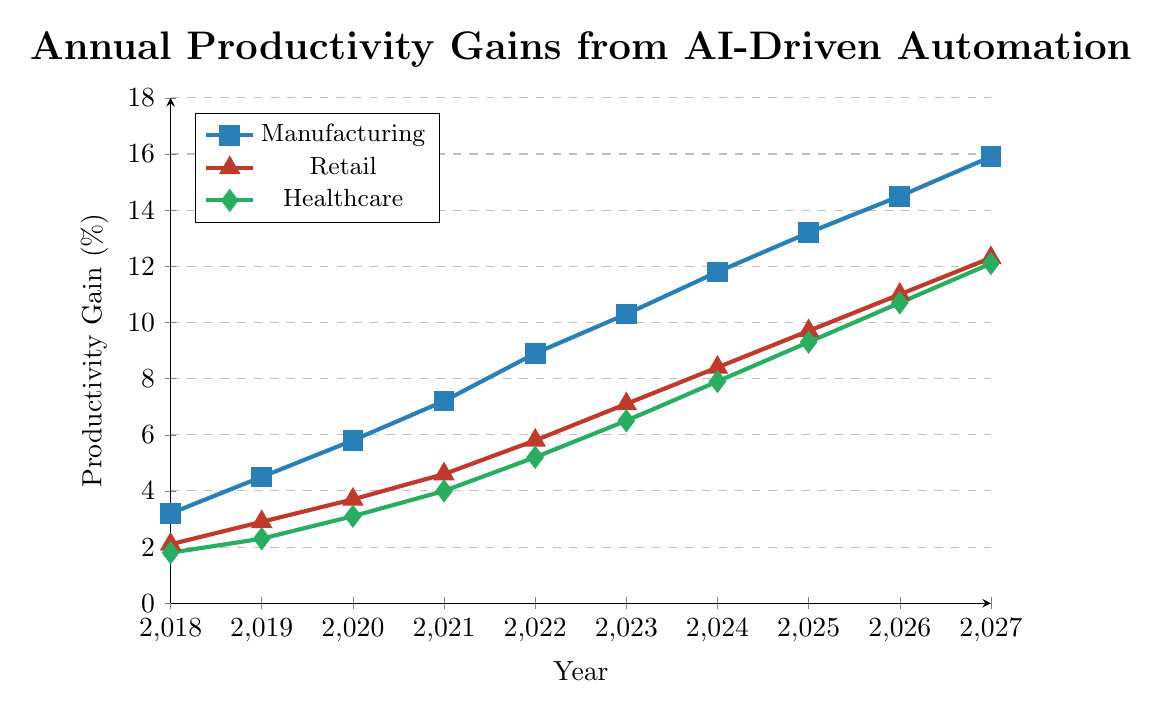What sector had the highest productivity gains in 2023? In 2023, compare the productivity gains across Manufacturing, Retail, and Healthcare sectors. Manufacturing shows 10.3%, Retail shows 7.1%, and Healthcare shows 6.5%. Thus, Manufacturing had the highest productivity gains.
Answer: Manufacturing How much did the productivity gain in the Healthcare sector increase from 2018 to 2027? Calculate the difference in productivity gains for the Healthcare sector between 2027 and 2018. It was 12.1% in 2027 and 1.8% in 2018. So, 12.1% - 1.8% = 10.3%.
Answer: 10.3% Which sector had the smallest productivity gain in 2020? For 2020, compare the productivity gains: Manufacturing 5.8%, Retail 3.7%, and Healthcare 3.1%. Healthcare had the smallest gain.
Answer: Healthcare What is the average productivity gain in the Retail sector from 2018 to 2022? Sum the productivity gains for Retail from 2018 to 2022: 2.1% + 2.9% + 3.7% + 4.6% + 5.8% = 19.1%. Then divide by the number of years: 19.1% / 5 = 3.82%.
Answer: 3.82% How does the growth in productivity gain from 2019 to 2020 in the Manufacturing sector compare to the growth in Retail? Calculate the increase in productivity gain from 2019 to 2020 for both sectors. Manufacturing: 5.8% - 4.5% = 1.3%. Retail: 3.7% - 2.9% = 0.8%. Manufacturing had a higher increase (1.3% vs. 0.8%).
Answer: Manufacturing had a higher increase What is the range of productivity gains in the Manufacturing sector in 2027? Identify the highest and lowest productivity gains in 2027 for the Manufacturing sector. The lowest gain is in 2018 with 3.2%, and the highest gain is in 2027 with 15.9%. The range is 15.9% - 3.2% = 12.7%.
Answer: 12.7% In which year did the Retail sector first exceed a productivity gain of 5%? Checking each year's productivity gain for Retail, the gain exceeds 5% in 2022 for the first time with 5.8%.
Answer: 2022 What was the difference in productivity gains between Manufacturing and Healthcare sectors in 2027? For 2027, subtract Healthcare's productivity gain from Manufacturing's productivity gain. Manufacturing was 15.9%, and Healthcare was 12.1%. So, 15.9% - 12.1% = 3.8%.
Answer: 3.8% How much did the productivity gain in Retail increase each year on average from 2018 to 2027? First, find the total increase in productivity gain from Retail in 2018 to 2027: 12.3% - 2.1% = 10.2%. Then divide by the number of years: 10.2% / 9 = 1.1333%.
Answer: 1.1333% Between 2021 and 2023, which sector exhibited the largest cumulative increase in productivity gain? Calculate the total increase for each sector between 2021 and 2023. Manufacturing: (10.3% - 7.2%) = 3.1%, Retail: (7.1% - 4.6%) = 2.5%, Healthcare: (6.5% - 4.0%) = 2.5%. Manufacturing had the largest cumulative increase.
Answer: Manufacturing 